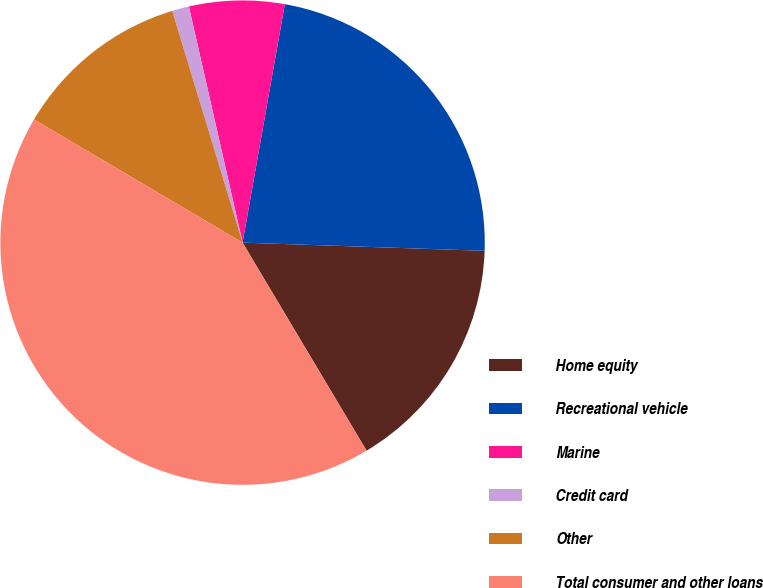<chart> <loc_0><loc_0><loc_500><loc_500><pie_chart><fcel>Home equity<fcel>Recreational vehicle<fcel>Marine<fcel>Credit card<fcel>Other<fcel>Total consumer and other loans<nl><fcel>15.91%<fcel>22.75%<fcel>6.35%<fcel>1.13%<fcel>11.82%<fcel>42.05%<nl></chart> 